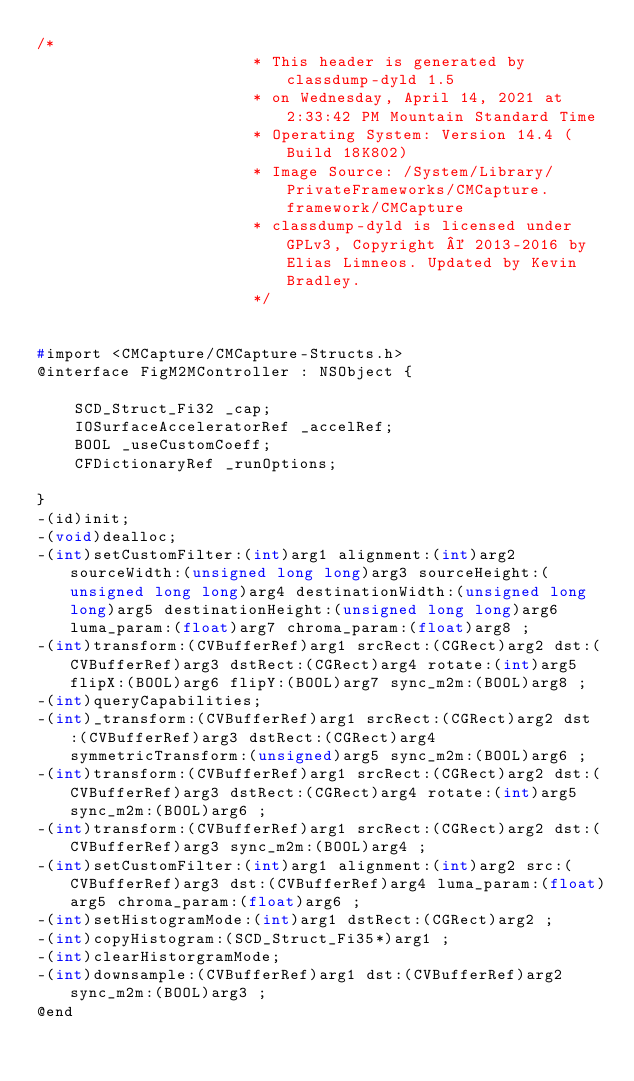<code> <loc_0><loc_0><loc_500><loc_500><_C_>/*
                       * This header is generated by classdump-dyld 1.5
                       * on Wednesday, April 14, 2021 at 2:33:42 PM Mountain Standard Time
                       * Operating System: Version 14.4 (Build 18K802)
                       * Image Source: /System/Library/PrivateFrameworks/CMCapture.framework/CMCapture
                       * classdump-dyld is licensed under GPLv3, Copyright © 2013-2016 by Elias Limneos. Updated by Kevin Bradley.
                       */


#import <CMCapture/CMCapture-Structs.h>
@interface FigM2MController : NSObject {

	SCD_Struct_Fi32 _cap;
	IOSurfaceAcceleratorRef _accelRef;
	BOOL _useCustomCoeff;
	CFDictionaryRef _runOptions;

}
-(id)init;
-(void)dealloc;
-(int)setCustomFilter:(int)arg1 alignment:(int)arg2 sourceWidth:(unsigned long long)arg3 sourceHeight:(unsigned long long)arg4 destinationWidth:(unsigned long long)arg5 destinationHeight:(unsigned long long)arg6 luma_param:(float)arg7 chroma_param:(float)arg8 ;
-(int)transform:(CVBufferRef)arg1 srcRect:(CGRect)arg2 dst:(CVBufferRef)arg3 dstRect:(CGRect)arg4 rotate:(int)arg5 flipX:(BOOL)arg6 flipY:(BOOL)arg7 sync_m2m:(BOOL)arg8 ;
-(int)queryCapabilities;
-(int)_transform:(CVBufferRef)arg1 srcRect:(CGRect)arg2 dst:(CVBufferRef)arg3 dstRect:(CGRect)arg4 symmetricTransform:(unsigned)arg5 sync_m2m:(BOOL)arg6 ;
-(int)transform:(CVBufferRef)arg1 srcRect:(CGRect)arg2 dst:(CVBufferRef)arg3 dstRect:(CGRect)arg4 rotate:(int)arg5 sync_m2m:(BOOL)arg6 ;
-(int)transform:(CVBufferRef)arg1 srcRect:(CGRect)arg2 dst:(CVBufferRef)arg3 sync_m2m:(BOOL)arg4 ;
-(int)setCustomFilter:(int)arg1 alignment:(int)arg2 src:(CVBufferRef)arg3 dst:(CVBufferRef)arg4 luma_param:(float)arg5 chroma_param:(float)arg6 ;
-(int)setHistogramMode:(int)arg1 dstRect:(CGRect)arg2 ;
-(int)copyHistogram:(SCD_Struct_Fi35*)arg1 ;
-(int)clearHistorgramMode;
-(int)downsample:(CVBufferRef)arg1 dst:(CVBufferRef)arg2 sync_m2m:(BOOL)arg3 ;
@end

</code> 